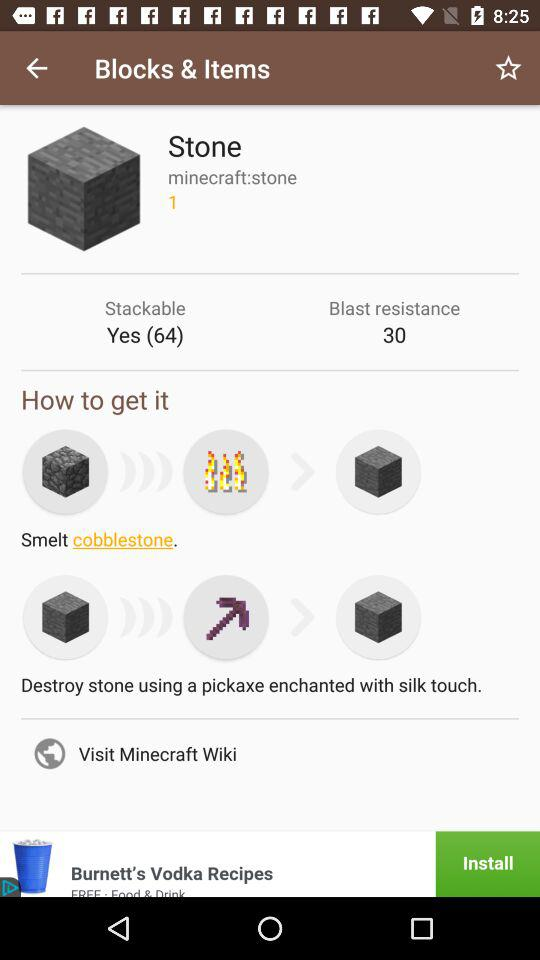What is the number for "Blast resistance"? The number for "Blast resistance" is 30. 